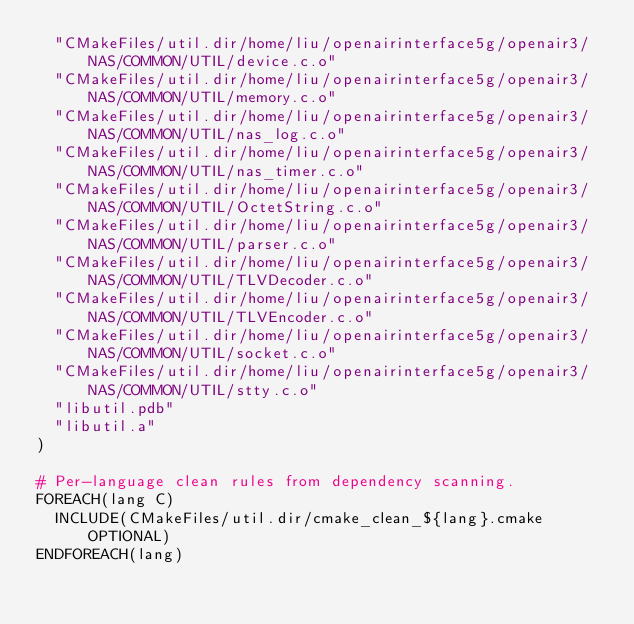<code> <loc_0><loc_0><loc_500><loc_500><_CMake_>  "CMakeFiles/util.dir/home/liu/openairinterface5g/openair3/NAS/COMMON/UTIL/device.c.o"
  "CMakeFiles/util.dir/home/liu/openairinterface5g/openair3/NAS/COMMON/UTIL/memory.c.o"
  "CMakeFiles/util.dir/home/liu/openairinterface5g/openair3/NAS/COMMON/UTIL/nas_log.c.o"
  "CMakeFiles/util.dir/home/liu/openairinterface5g/openair3/NAS/COMMON/UTIL/nas_timer.c.o"
  "CMakeFiles/util.dir/home/liu/openairinterface5g/openair3/NAS/COMMON/UTIL/OctetString.c.o"
  "CMakeFiles/util.dir/home/liu/openairinterface5g/openair3/NAS/COMMON/UTIL/parser.c.o"
  "CMakeFiles/util.dir/home/liu/openairinterface5g/openair3/NAS/COMMON/UTIL/TLVDecoder.c.o"
  "CMakeFiles/util.dir/home/liu/openairinterface5g/openair3/NAS/COMMON/UTIL/TLVEncoder.c.o"
  "CMakeFiles/util.dir/home/liu/openairinterface5g/openair3/NAS/COMMON/UTIL/socket.c.o"
  "CMakeFiles/util.dir/home/liu/openairinterface5g/openair3/NAS/COMMON/UTIL/stty.c.o"
  "libutil.pdb"
  "libutil.a"
)

# Per-language clean rules from dependency scanning.
FOREACH(lang C)
  INCLUDE(CMakeFiles/util.dir/cmake_clean_${lang}.cmake OPTIONAL)
ENDFOREACH(lang)
</code> 